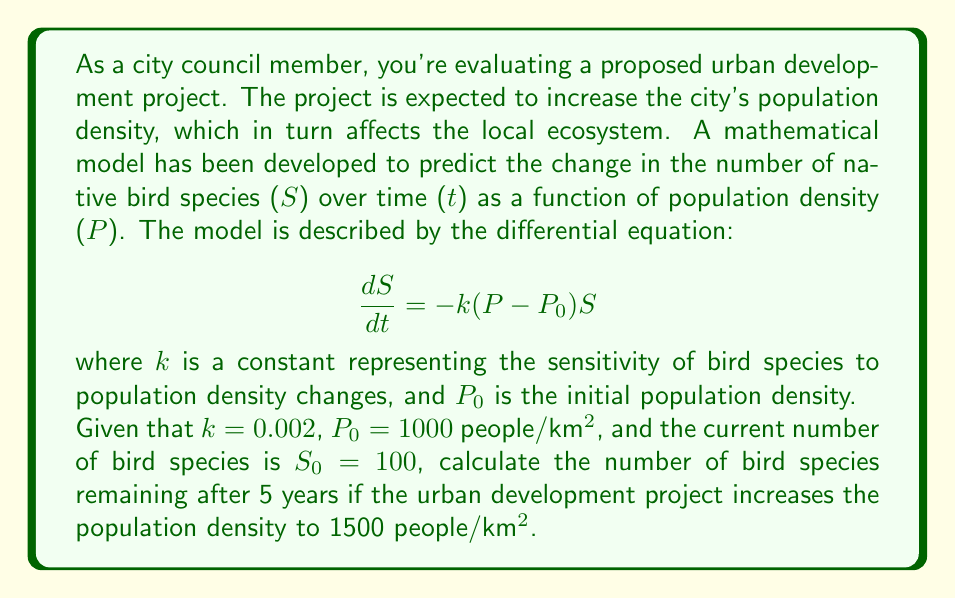Help me with this question. To solve this problem, we need to integrate the given differential equation and apply the initial conditions. Let's break it down step by step:

1) The differential equation is:

   $$\frac{dS}{dt} = -k(P-P_0)S$$

2) Rearranging the equation:

   $$\frac{dS}{S} = -k(P-P_0)dt$$

3) Integrating both sides:

   $$\int_{S_0}^S \frac{dS}{S} = -k(P-P_0)\int_0^t dt$$

4) Solving the integrals:

   $$\ln(\frac{S}{S_0}) = -k(P-P_0)t$$

5) Exponentiating both sides:

   $$\frac{S}{S_0} = e^{-k(P-P_0)t}$$

6) Solving for S:

   $$S = S_0e^{-k(P-P_0)t}$$

7) Now, let's plug in the given values:
   $k = 0.002$
   $P = 1500$ people/km²
   $P_0 = 1000$ people/km²
   $S_0 = 100$ species
   $t = 5$ years

   $$S = 100e^{-0.002(1500-1000)5}$$

8) Simplifying:

   $$S = 100e^{-0.002 \times 500 \times 5} = 100e^{-5}$$

9) Calculating the final result:

   $$S \approx 100 \times 0.00674 \approx 0.674$$
Answer: After 5 years, approximately 0.67 bird species will remain, which in practical terms means that nearly all native bird species will be lost due to the urban development project. 